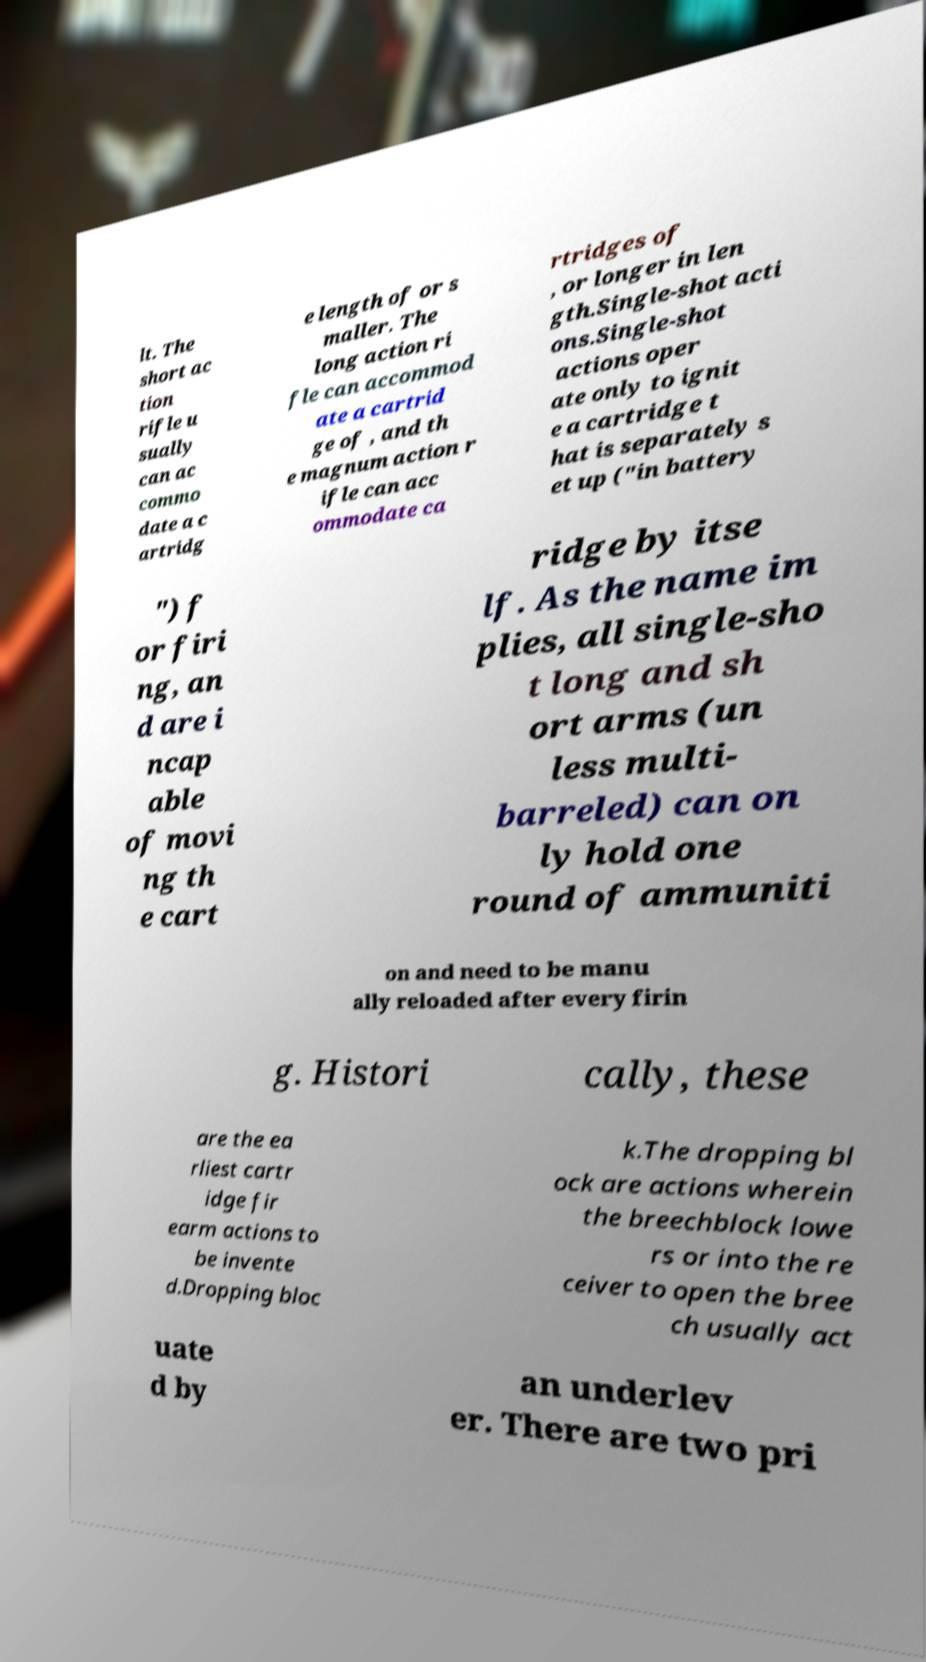I need the written content from this picture converted into text. Can you do that? lt. The short ac tion rifle u sually can ac commo date a c artridg e length of or s maller. The long action ri fle can accommod ate a cartrid ge of , and th e magnum action r ifle can acc ommodate ca rtridges of , or longer in len gth.Single-shot acti ons.Single-shot actions oper ate only to ignit e a cartridge t hat is separately s et up ("in battery ") f or firi ng, an d are i ncap able of movi ng th e cart ridge by itse lf. As the name im plies, all single-sho t long and sh ort arms (un less multi- barreled) can on ly hold one round of ammuniti on and need to be manu ally reloaded after every firin g. Histori cally, these are the ea rliest cartr idge fir earm actions to be invente d.Dropping bloc k.The dropping bl ock are actions wherein the breechblock lowe rs or into the re ceiver to open the bree ch usually act uate d by an underlev er. There are two pri 